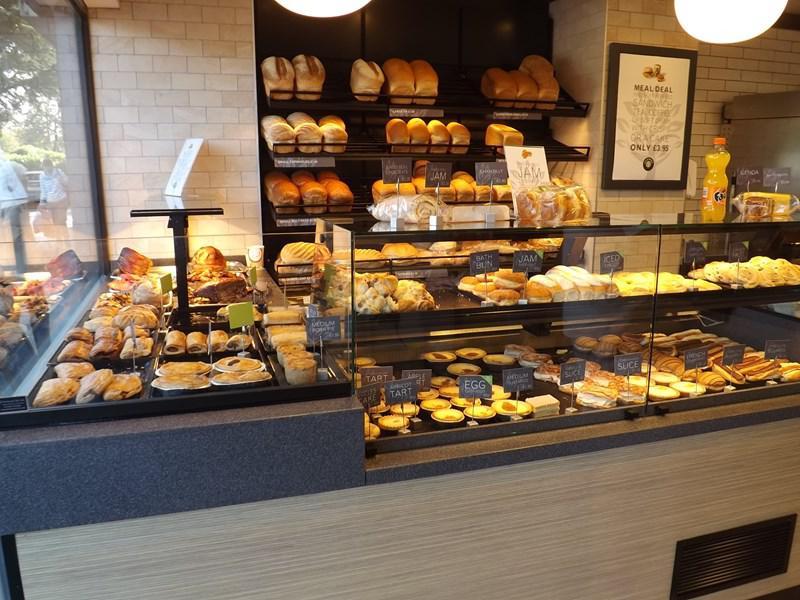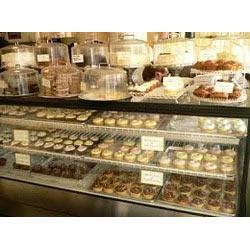The first image is the image on the left, the second image is the image on the right. For the images displayed, is the sentence "An image includes a bakery worker wearing a hat." factually correct? Answer yes or no. No. The first image is the image on the left, the second image is the image on the right. Given the left and right images, does the statement "At least one bakery worker is shown in at least one image." hold true? Answer yes or no. No. 